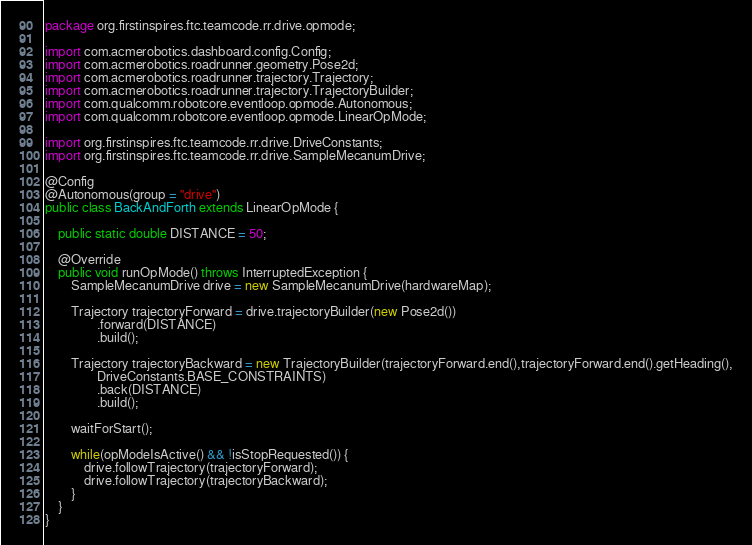Convert code to text. <code><loc_0><loc_0><loc_500><loc_500><_Java_>package org.firstinspires.ftc.teamcode.rr.drive.opmode;

import com.acmerobotics.dashboard.config.Config;
import com.acmerobotics.roadrunner.geometry.Pose2d;
import com.acmerobotics.roadrunner.trajectory.Trajectory;
import com.acmerobotics.roadrunner.trajectory.TrajectoryBuilder;
import com.qualcomm.robotcore.eventloop.opmode.Autonomous;
import com.qualcomm.robotcore.eventloop.opmode.LinearOpMode;

import org.firstinspires.ftc.teamcode.rr.drive.DriveConstants;
import org.firstinspires.ftc.teamcode.rr.drive.SampleMecanumDrive;

@Config
@Autonomous(group = "drive")
public class BackAndForth extends LinearOpMode {

    public static double DISTANCE = 50;

    @Override
    public void runOpMode() throws InterruptedException {
        SampleMecanumDrive drive = new SampleMecanumDrive(hardwareMap);

        Trajectory trajectoryForward = drive.trajectoryBuilder(new Pose2d())
                .forward(DISTANCE)
                .build();

        Trajectory trajectoryBackward = new TrajectoryBuilder(trajectoryForward.end(),trajectoryForward.end().getHeading(),
                DriveConstants.BASE_CONSTRAINTS)
                .back(DISTANCE)
                .build();

        waitForStart();

        while(opModeIsActive() && !isStopRequested()) {
            drive.followTrajectory(trajectoryForward);
            drive.followTrajectory(trajectoryBackward);
        }
    }
}</code> 